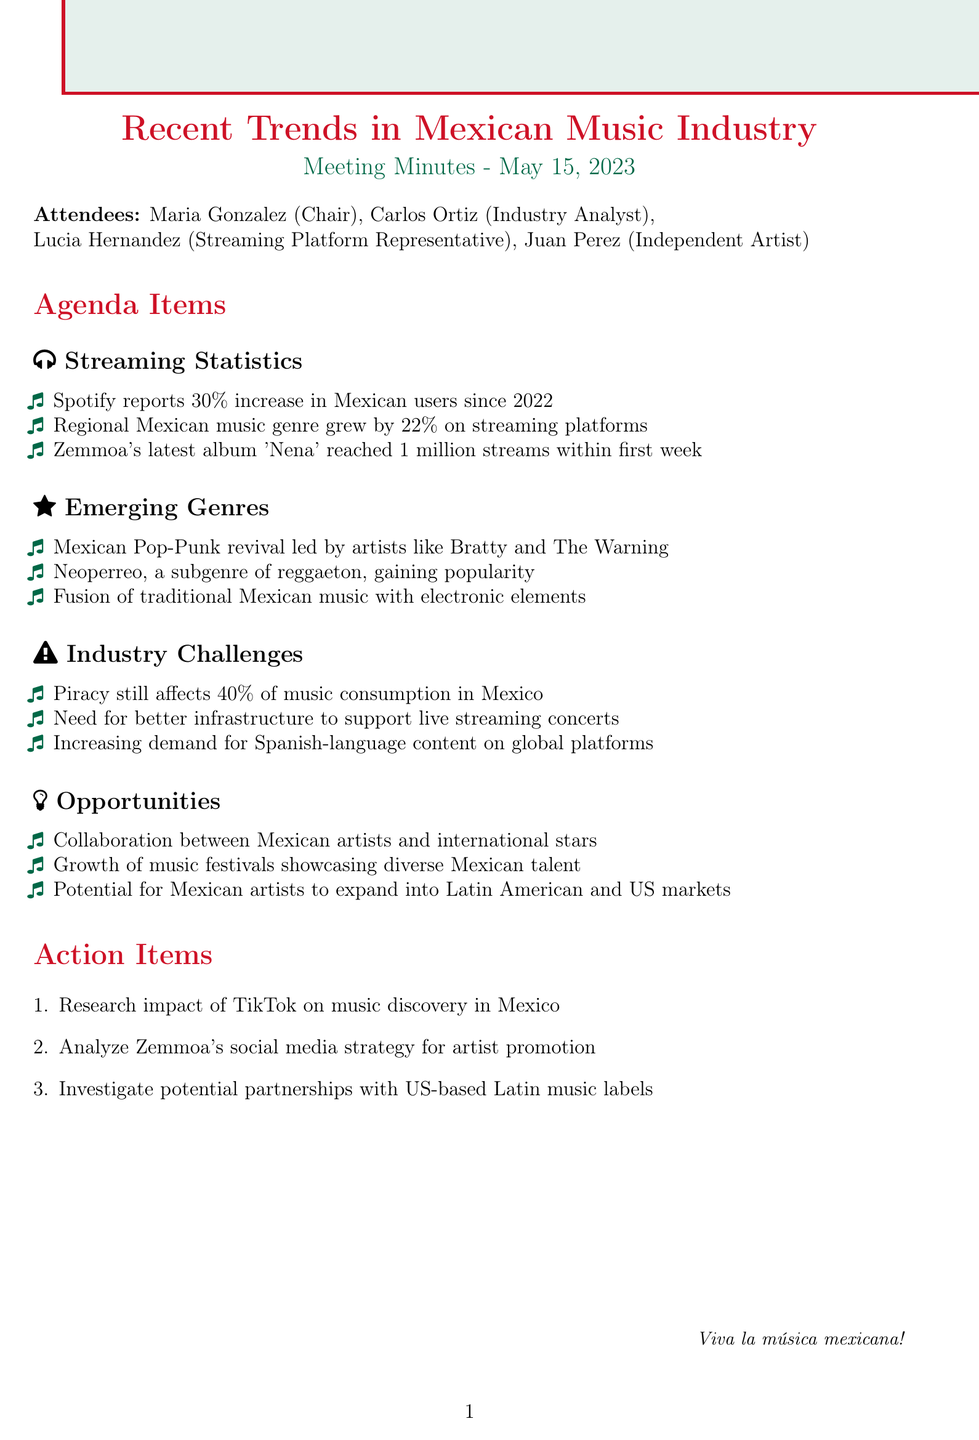What is the date of the meeting? The date is stated in the document under the title and is implemented as part of the meeting minutes.
Answer: 2023-05-15 Who chaired the meeting? The chairperson's name is listed in the attendees section of the document.
Answer: Maria Gonzalez What was the percentage increase in Mexican Spotify users since 2022? The document contains specific statistics regarding user growth, noted in the Streaming Statistics section.
Answer: 30% Which genre grew by 22% on streaming platforms? The document mentions this statistic in relation to music genre growth under Streaming Statistics.
Answer: Regional Mexican music Who are some artists leading the Mexican Pop-Punk revival? The document enumerates specific artists associated with this emerging genre in the Emerging Genres section.
Answer: Bratty and The Warning What challenge affects 40% of music consumption in Mexico? This information is included in the Industry Challenges section of the document, which covers different issues in the industry.
Answer: Piracy What is one opportunity for Mexican artists mentioned in the meeting? The Opportunities section summarizes favorable developments for artists, referencing specific trends or collaborations.
Answer: Collaboration between Mexican artists and international stars What are the action items listed in the document? The action items are explicitly outlined at the end of the meeting minutes, providing future directions as discussed in the meeting.
Answer: Research impact of TikTok on music discovery in Mexico What emerging genre is gaining popularity alongside reggaeton? The document specifically names this genre in the Emerging Genres section while describing current trends.
Answer: Neoperreo 